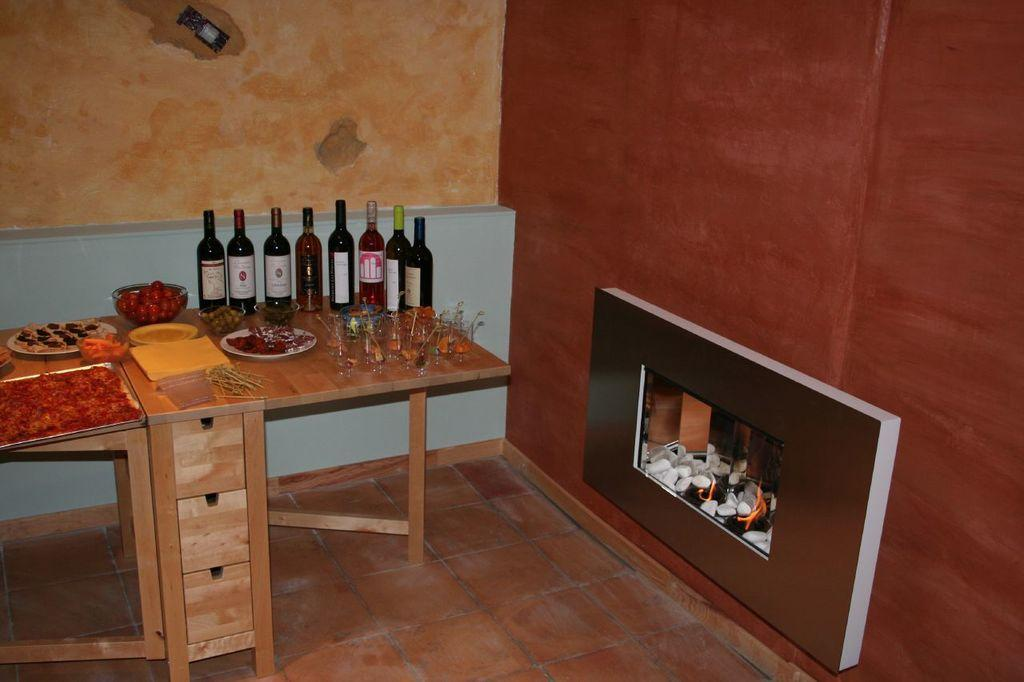What type of beverage containers are present in the image? There are wine bottles in the image. What else can be seen in the image besides the wine bottles? There are food items and other objects on a wooden table in the image. What type of structure can be seen in the background of the image? There are walls visible in the image. What architectural feature is present in the room? There is a fireplace in the image. What time does the clock show in the image? There is no clock present in the image, so it is not possible to determine the time. 